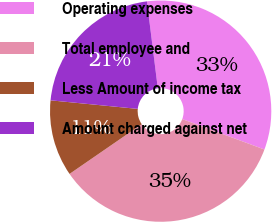Convert chart to OTSL. <chart><loc_0><loc_0><loc_500><loc_500><pie_chart><fcel>Operating expenses<fcel>Total employee and<fcel>Less Amount of income tax<fcel>Amount charged against net<nl><fcel>32.62%<fcel>34.76%<fcel>11.16%<fcel>21.46%<nl></chart> 